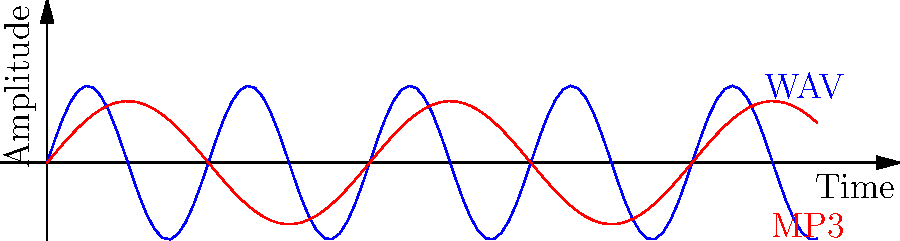Based on the waveform representations shown in the image, which audio file format is likely to have a higher bitrate and better audio quality? To answer this question, let's analyze the waveforms step by step:

1. Observe the blue waveform:
   - It has a higher frequency (more cycles per unit time)
   - It has a larger amplitude (greater distance from peak to trough)

2. Observe the red waveform:
   - It has a lower frequency (fewer cycles per unit time)
   - It has a slightly smaller amplitude

3. Understand audio file characteristics:
   - Higher bitrate files can store more data per second
   - More data allows for higher frequencies and a wider dynamic range

4. Compare WAV and MP3 formats:
   - WAV is typically an uncompressed format, preserving original audio quality
   - MP3 is a compressed format, often reducing file size by removing some audio data

5. Relate waveforms to file formats:
   - The blue waveform, with higher frequency and amplitude, likely represents WAV
   - The red waveform, with lower frequency and amplitude, likely represents MP3

6. Conclude:
   - The WAV format (blue waveform) would have a higher bitrate and better audio quality
Answer: WAV 